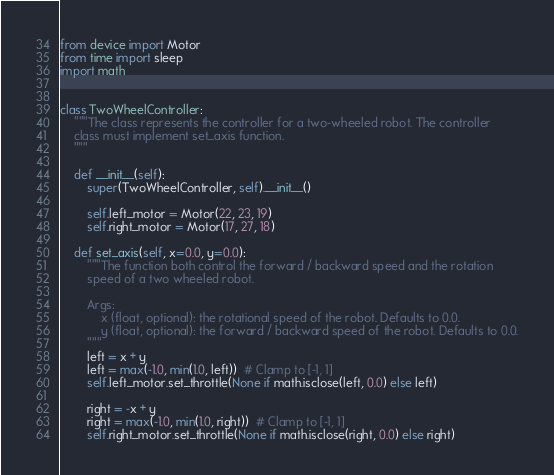<code> <loc_0><loc_0><loc_500><loc_500><_Python_>from device import Motor
from time import sleep
import math


class TwoWheelController:
    """The class represents the controller for a two-wheeled robot. The controller
    class must implement set_axis function.
    """

    def __init__(self):
        super(TwoWheelController, self).__init__()

        self.left_motor = Motor(22, 23, 19)
        self.right_motor = Motor(17, 27, 18)

    def set_axis(self, x=0.0, y=0.0):
        """The function both control the forward / backward speed and the rotation
        speed of a two wheeled robot.

        Args:
            x (float, optional): the rotational speed of the robot. Defaults to 0.0.
            y (float, optional): the forward / backward speed of the robot. Defaults to 0.0.
        """
        left = x + y
        left = max(-1.0, min(1.0, left))  # Clamp to [-1, 1]
        self.left_motor.set_throttle(None if math.isclose(left, 0.0) else left)

        right = -x + y
        right = max(-1.0, min(1.0, right))  # Clamp to [-1, 1]
        self.right_motor.set_throttle(None if math.isclose(right, 0.0) else right)
</code> 